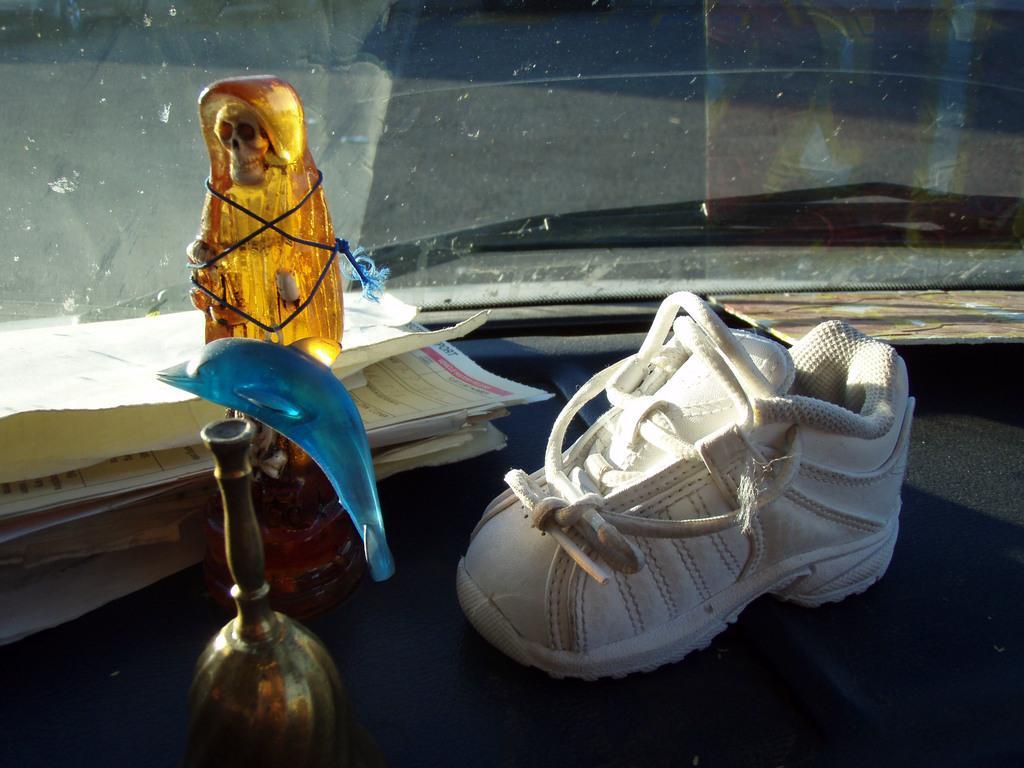Please provide a concise description of this image. In this picture we can see a white shoe on an object and in front of the show there are papers and some items. Behind the show there is a glass. 